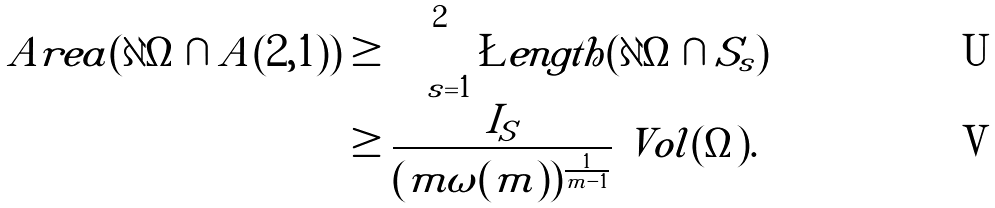Convert formula to latex. <formula><loc_0><loc_0><loc_500><loc_500>\ A r e a ( \partial \Omega \cap A ( 2 , 1 ) ) & \geq \int _ { s = 1 } ^ { 2 } \L e n g t h ( \partial \Omega \cap S _ { s } ) \\ & \geq \frac { I _ { S } } { ( m \omega ( m ) ) ^ { \frac { 1 } { m - 1 } } } \ V o l ( \Omega ) .</formula> 